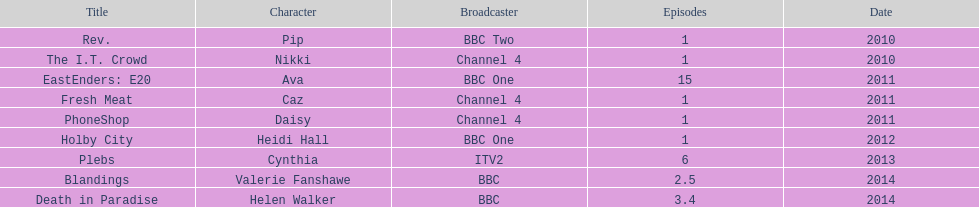Can you parse all the data within this table? {'header': ['Title', 'Character', 'Broadcaster', 'Episodes', 'Date'], 'rows': [['Rev.', 'Pip', 'BBC Two', '1', '2010'], ['The I.T. Crowd', 'Nikki', 'Channel 4', '1', '2010'], ['EastEnders: E20', 'Ava', 'BBC One', '15', '2011'], ['Fresh Meat', 'Caz', 'Channel 4', '1', '2011'], ['PhoneShop', 'Daisy', 'Channel 4', '1', '2011'], ['Holby City', 'Heidi Hall', 'BBC One', '1', '2012'], ['Plebs', 'Cynthia', 'ITV2', '6', '2013'], ['Blandings', 'Valerie Fanshawe', 'BBC', '2.5', '2014'], ['Death in Paradise', 'Helen Walker', 'BBC', '3.4', '2014']]} Blandings and death in paradise both premiered on which network? BBC. 